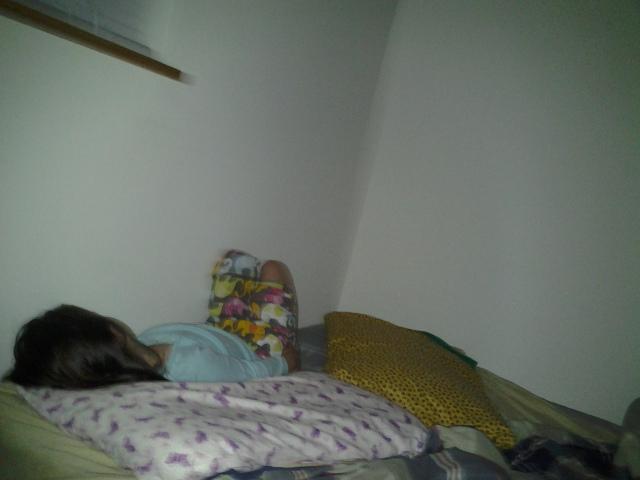Is the pillow red?
Give a very brief answer. No. Is there a child on the bed?
Short answer required. Yes. How many pillows are there?
Be succinct. 2. Is there a fireplace in this room?
Keep it brief. No. What kind of room is this?
Answer briefly. Bedroom. 